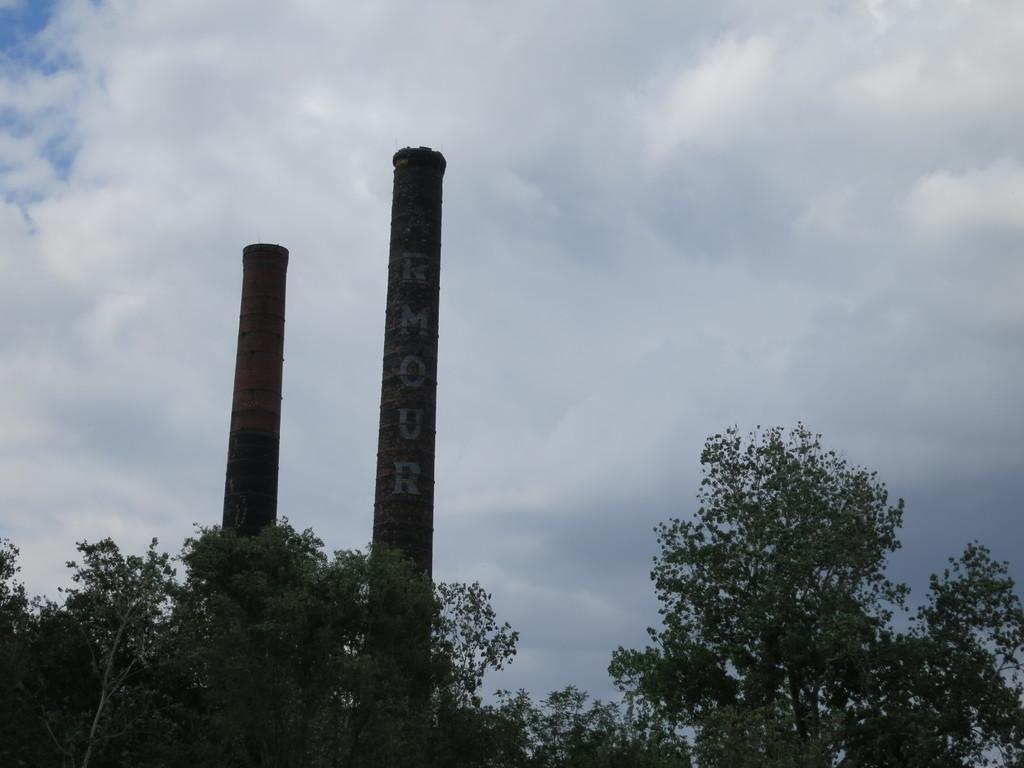What type of vegetation can be seen in the image? There are trees in the image. What is located in the middle of the trees? There are two poles with something written on them in the middle of the trees. What is visible at the top of the image? The sky is visible at the top of the image. What can be seen in the sky? Clouds are present in the sky. What type of copper material can be seen in the image? There is no copper material present in the image. What type of card is being used by the cattle in the image? There are no cattle or cards present in the image. 